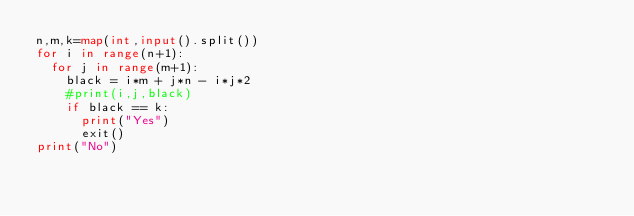<code> <loc_0><loc_0><loc_500><loc_500><_Python_>n,m,k=map(int,input().split())
for i in range(n+1):
  for j in range(m+1):
    black = i*m + j*n - i*j*2
    #print(i,j,black)
    if black == k:
      print("Yes")
      exit()
print("No")
</code> 